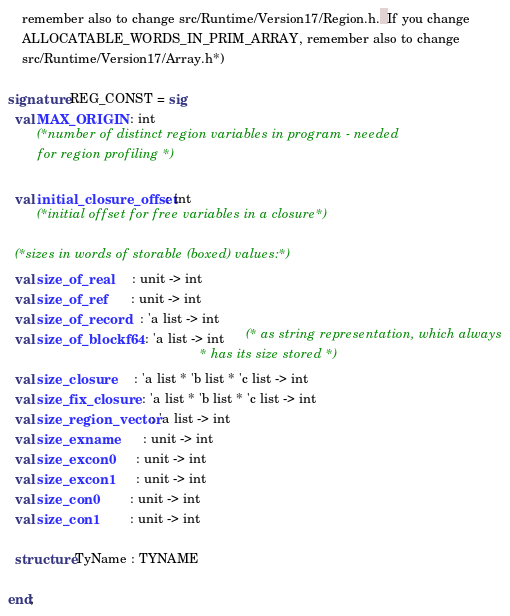Convert code to text. <code><loc_0><loc_0><loc_500><loc_500><_SML_>    remember also to change src/Runtime/Version17/Region.h.  If you change
    ALLOCATABLE_WORDS_IN_PRIM_ARRAY, remember also to change
    src/Runtime/Version17/Array.h*)

signature REG_CONST = sig
  val MAX_ORIGIN : int
        (*number of distinct region variables in program - needed
  	  for region profiling *)

  val initial_closure_offset : int
        (*initial offset for free variables in a closure*)

  (*sizes in words of storable (boxed) values:*)
  val size_of_real       : unit -> int
  val size_of_ref        : unit -> int
  val size_of_record     : 'a list -> int
  val size_of_blockf64   : 'a list -> int      (* as string representation, which always
                                                * has its size stored *)
  val size_closure       : 'a list * 'b list * 'c list -> int
  val size_fix_closure   : 'a list * 'b list * 'c list -> int
  val size_region_vector : 'a list -> int
  val size_exname        : unit -> int
  val size_excon0        : unit -> int
  val size_excon1        : unit -> int
  val size_con0          : unit -> int
  val size_con1          : unit -> int

  structure TyName : TYNAME

end;
</code> 